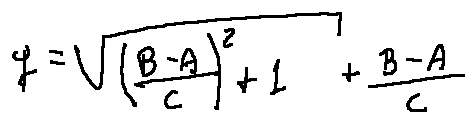<formula> <loc_0><loc_0><loc_500><loc_500>q = \sqrt { ( \frac { B - A } { C } ) ^ { 2 } + 1 } + \frac { B - A } { C }</formula> 